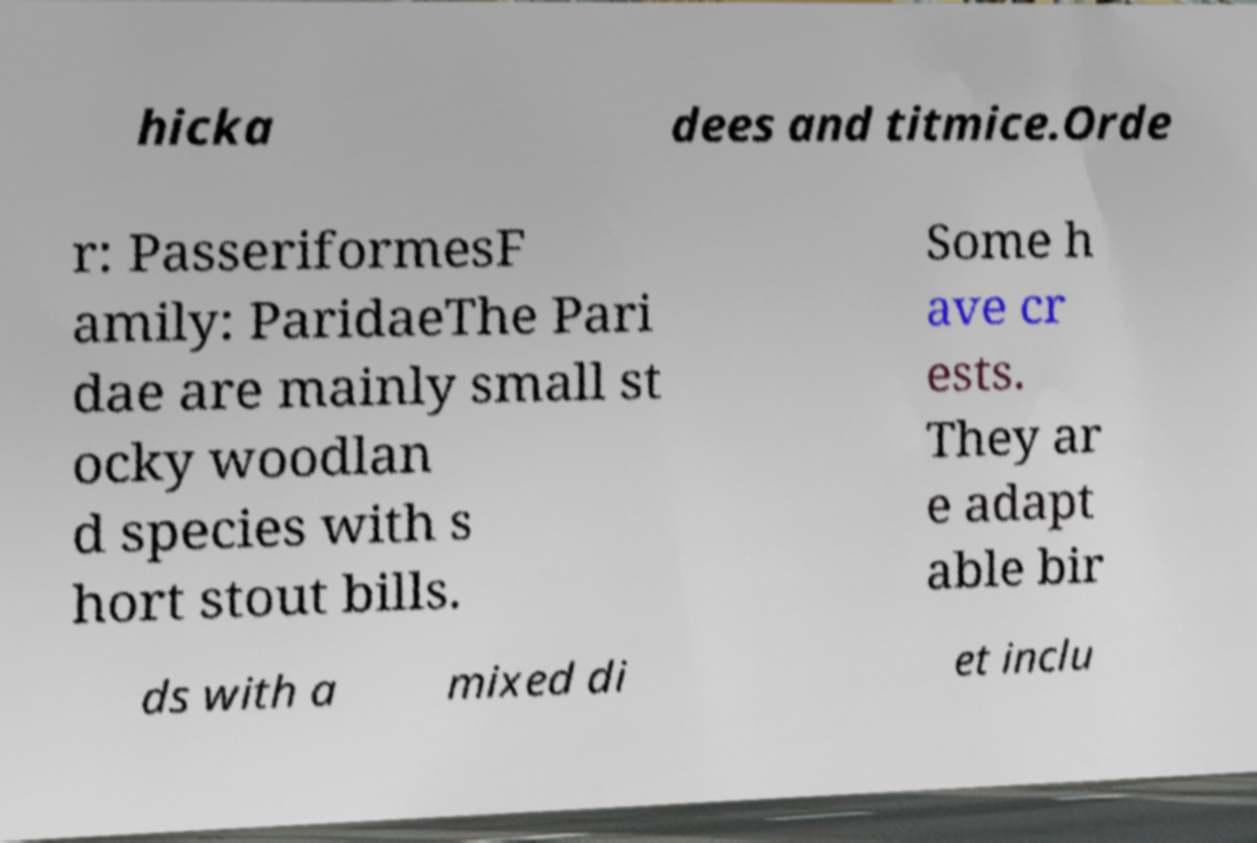Please identify and transcribe the text found in this image. hicka dees and titmice.Orde r: PasseriformesF amily: ParidaeThe Pari dae are mainly small st ocky woodlan d species with s hort stout bills. Some h ave cr ests. They ar e adapt able bir ds with a mixed di et inclu 